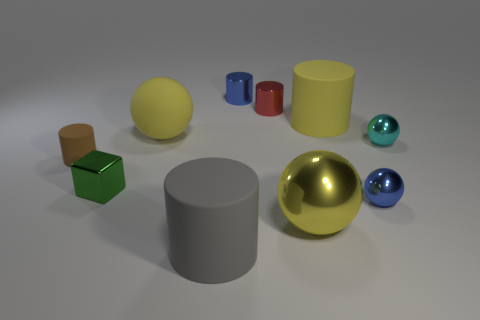What shape is the matte thing that is the same color as the matte sphere?
Offer a very short reply. Cylinder. Is the color of the big shiny thing the same as the large matte sphere?
Provide a short and direct response. Yes. The yellow matte thing that is the same shape as the large gray object is what size?
Offer a very short reply. Large. What number of metal balls have the same size as the green object?
Keep it short and to the point. 2. Is the number of red cylinders behind the red shiny thing greater than the number of cyan spheres to the left of the big yellow rubber ball?
Offer a terse response. No. Is there a small red shiny thing of the same shape as the big yellow shiny object?
Offer a terse response. No. What size is the blue shiny thing behind the yellow object to the right of the big yellow metal thing?
Keep it short and to the point. Small. There is a object to the right of the small thing in front of the green metal block that is behind the big shiny object; what is its shape?
Make the answer very short. Sphere. There is a yellow cylinder that is the same material as the brown cylinder; what size is it?
Your answer should be very brief. Large. Is the number of brown cylinders greater than the number of brown metal balls?
Your answer should be very brief. Yes. 